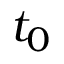<formula> <loc_0><loc_0><loc_500><loc_500>t _ { 0 }</formula> 